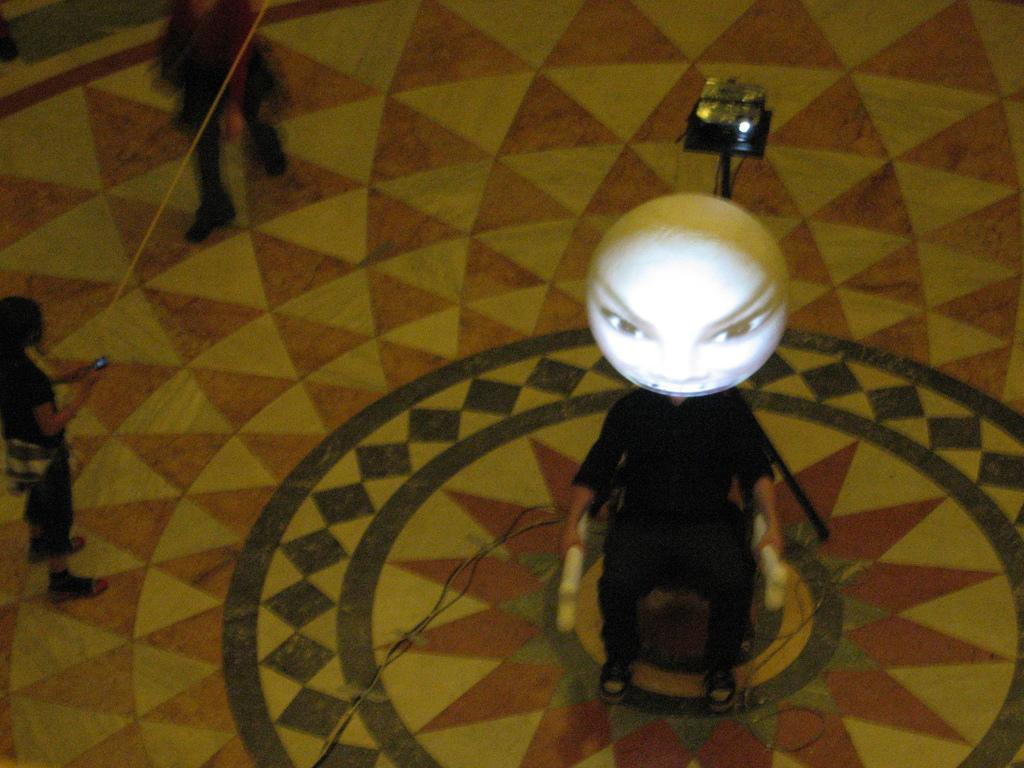What can be seen in the image in terms of human presence? There are people standing in the image. Where are the people standing? The people are standing on the floor. What type of machine is present in the image? There is an electronic machine in the image. What else can be found on the floor in the image? There are other objects on the floor in the image. What angle does the representative use to approach the example in the image? There is no representative or example present in the image; it only features people standing on the floor, an electronic machine, and other objects. 